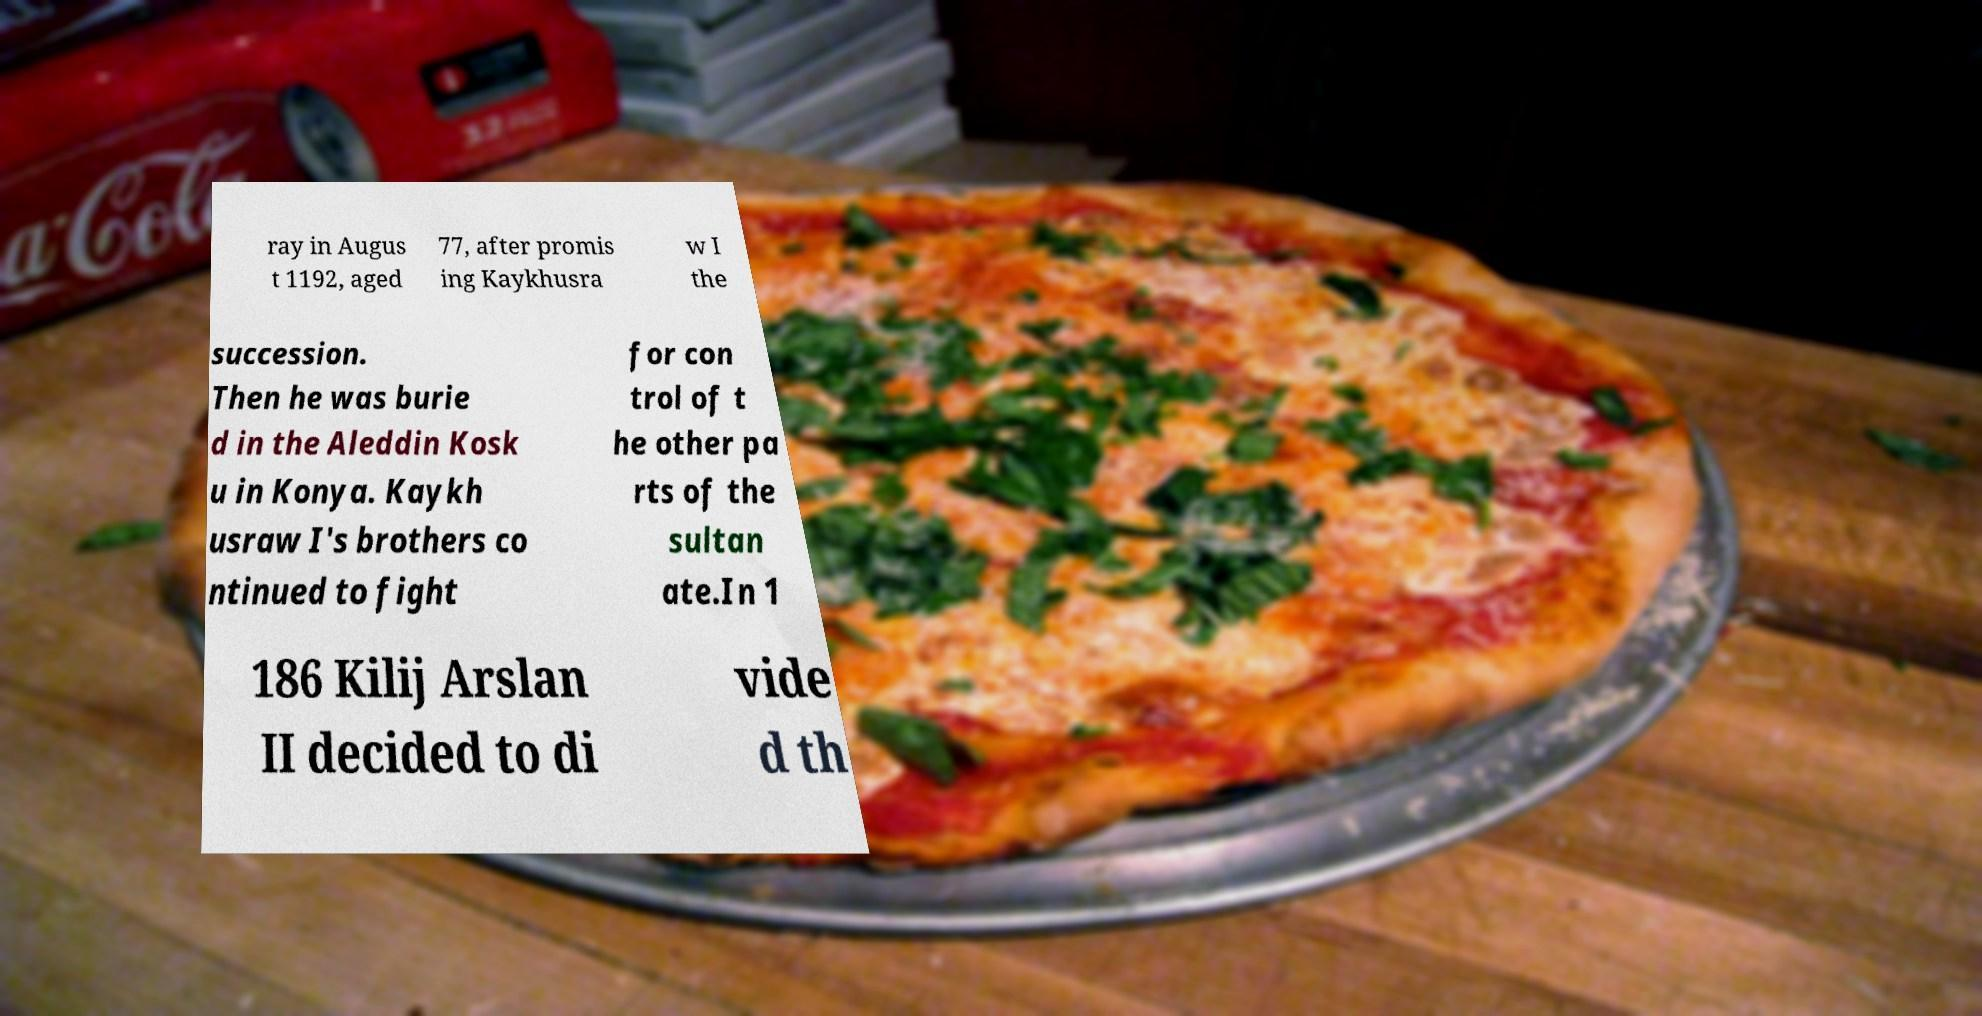Could you extract and type out the text from this image? ray in Augus t 1192, aged 77, after promis ing Kaykhusra w I the succession. Then he was burie d in the Aleddin Kosk u in Konya. Kaykh usraw I's brothers co ntinued to fight for con trol of t he other pa rts of the sultan ate.In 1 186 Kilij Arslan II decided to di vide d th 